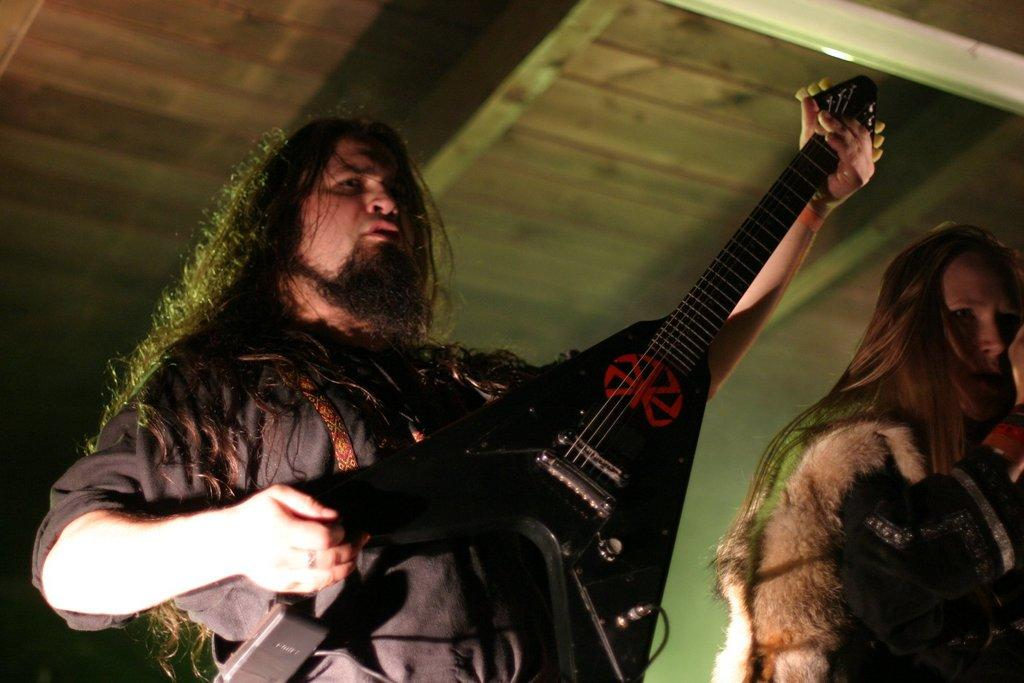What is the man in the image doing? The man is playing a guitar in the image. Who is with the man in the image? There is a woman standing beside the man in the image. What can be seen in the background of the image? There is a roof visible in the background of the image. What type of tin is the man using to play the guitar in the image? There is no tin present in the image; the man is playing a traditional guitar. 